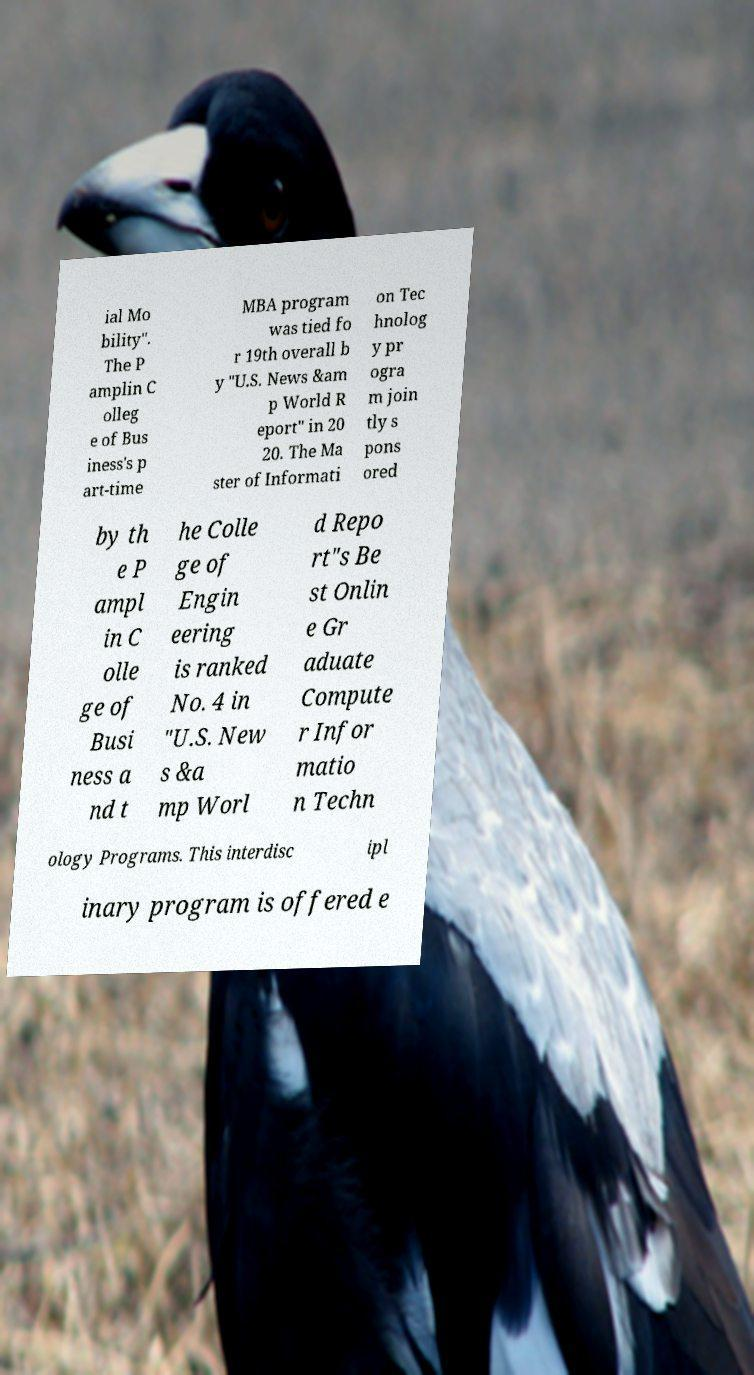Please read and relay the text visible in this image. What does it say? ial Mo bility". The P amplin C olleg e of Bus iness's p art-time MBA program was tied fo r 19th overall b y "U.S. News &am p World R eport" in 20 20. The Ma ster of Informati on Tec hnolog y pr ogra m join tly s pons ored by th e P ampl in C olle ge of Busi ness a nd t he Colle ge of Engin eering is ranked No. 4 in "U.S. New s &a mp Worl d Repo rt"s Be st Onlin e Gr aduate Compute r Infor matio n Techn ology Programs. This interdisc ipl inary program is offered e 